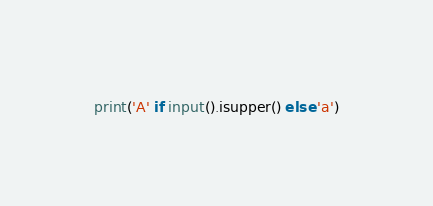<code> <loc_0><loc_0><loc_500><loc_500><_Python_>print('A' if input().isupper() else 'a')</code> 